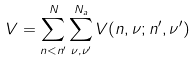<formula> <loc_0><loc_0><loc_500><loc_500>V = \sum _ { n < n ^ { \prime } } ^ { N } \sum _ { \nu , \nu ^ { \prime } } ^ { N _ { a } } V ( n , \nu ; n ^ { \prime } , \nu ^ { \prime } )</formula> 